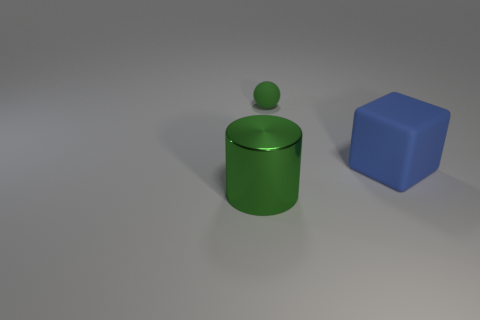Add 1 big cyan rubber objects. How many objects exist? 4 Subtract all cylinders. How many objects are left? 2 Subtract all large blue blocks. Subtract all gray balls. How many objects are left? 2 Add 1 rubber cubes. How many rubber cubes are left? 2 Add 1 large shiny objects. How many large shiny objects exist? 2 Subtract 0 purple balls. How many objects are left? 3 